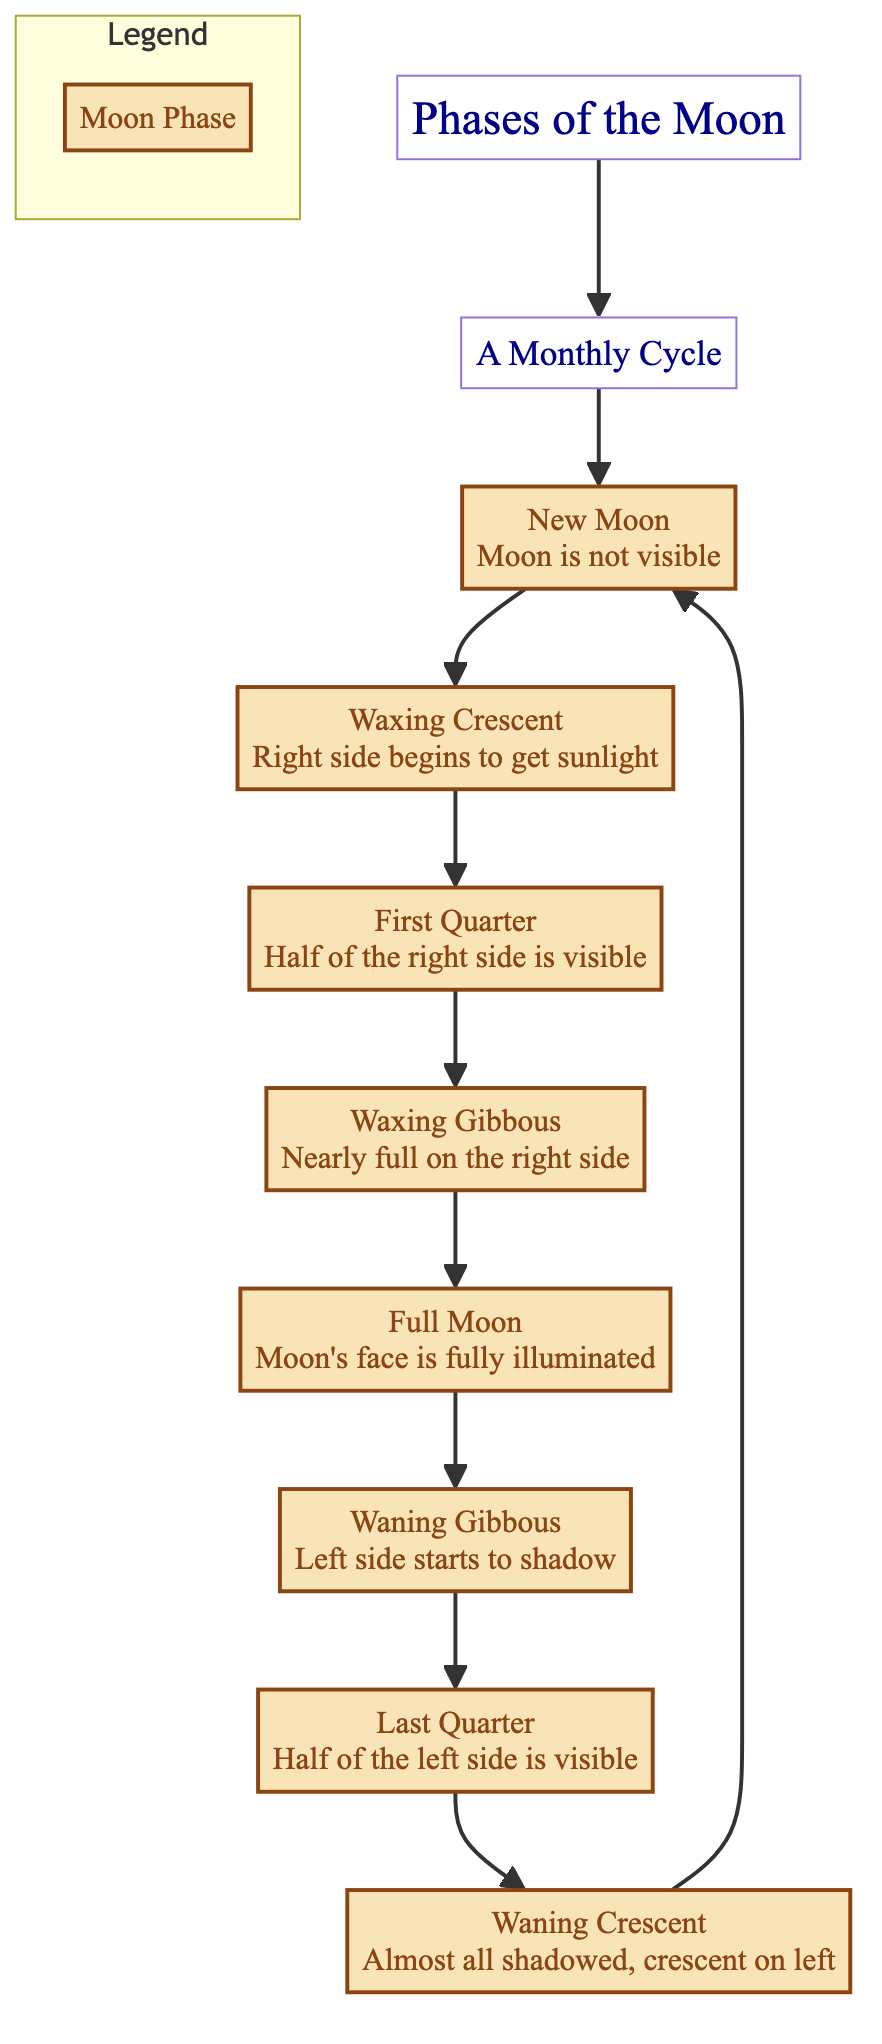What is the first phase of the moon depicted in the diagram? The diagram starts with the "New Moon" phase, which is the first phase visible in the sequence presented.
Answer: New Moon How many phases of the moon are illustrated in the diagram? The diagram displays a total of eight distinct phases of the moon, including "New Moon" and "Waning Crescent."
Answer: Eight What is the last phase before returning to the New Moon? According to the flow of the diagram, the last phase before cycling back to "New Moon" is "Waning Crescent."
Answer: Waning Crescent Which phase occurs just after the Half Moon? The "Waxing Gibbous" phase directly follows the "First Quarter" (referred to as Half Moon) in the progression shown in the diagram.
Answer: Waxing Gibbous What is the relationship between the Full Moon and Waning Gibbous phases? The "Waning Gibbous" phase comes immediately after the "Full Moon," indicating that the light is starting to decrease as the moon transitions to a shadowed state.
Answer: Comes after Where does the Waxing Crescent phase fall in the order of phases? "Waxing Crescent" is the second phase in the sequence, immediately following the "New Moon."
Answer: Second Which phase has light visible only on the right side? In the sequence, the "First Quarter" phase has its light illuminated only on the right side of the moon.
Answer: First Quarter What represents the transition from illumination to shadow on the left side? The transition from illumination to shadow on the left side is represented by the "Waning Gibbous" phase, as it indicates the moon is shedding light after the full visibility of the "Full Moon."
Answer: Waning Gibbous What is the significance of the title "Phases of the Moon"? The title indicates that the diagram illustrates the various stages of the moon's visibility over a monthly cycle, which are traditionally recognized.
Answer: Illustrates stages of moon visibility 